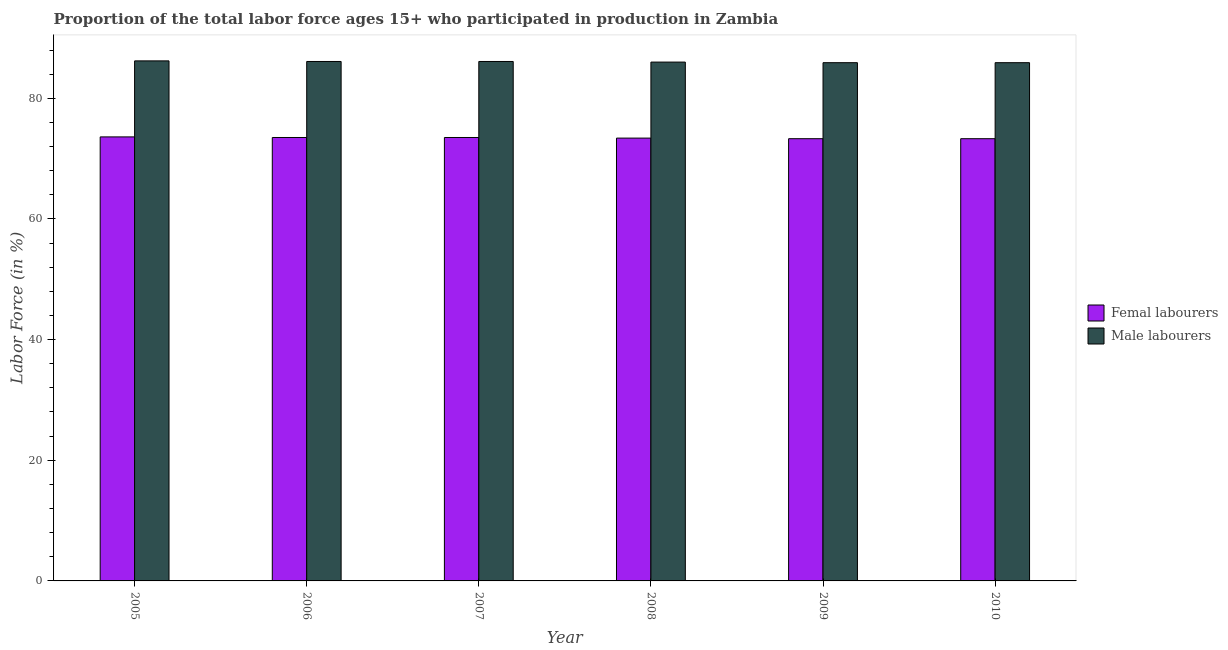How many different coloured bars are there?
Ensure brevity in your answer.  2. How many groups of bars are there?
Your answer should be very brief. 6. Are the number of bars on each tick of the X-axis equal?
Your response must be concise. Yes. How many bars are there on the 3rd tick from the right?
Keep it short and to the point. 2. What is the label of the 1st group of bars from the left?
Keep it short and to the point. 2005. What is the percentage of male labour force in 2006?
Provide a short and direct response. 86.1. Across all years, what is the maximum percentage of male labour force?
Offer a very short reply. 86.2. Across all years, what is the minimum percentage of female labor force?
Provide a short and direct response. 73.3. In which year was the percentage of female labor force minimum?
Ensure brevity in your answer.  2009. What is the total percentage of male labour force in the graph?
Make the answer very short. 516.2. What is the difference between the percentage of female labor force in 2009 and that in 2010?
Offer a terse response. 0. What is the difference between the percentage of female labor force in 2006 and the percentage of male labour force in 2010?
Your answer should be very brief. 0.2. What is the average percentage of female labor force per year?
Your response must be concise. 73.43. What is the ratio of the percentage of male labour force in 2005 to that in 2007?
Your response must be concise. 1. What is the difference between the highest and the second highest percentage of male labour force?
Keep it short and to the point. 0.1. What is the difference between the highest and the lowest percentage of female labor force?
Make the answer very short. 0.3. Is the sum of the percentage of female labor force in 2007 and 2008 greater than the maximum percentage of male labour force across all years?
Give a very brief answer. Yes. What does the 2nd bar from the left in 2006 represents?
Provide a short and direct response. Male labourers. What does the 2nd bar from the right in 2009 represents?
Your response must be concise. Femal labourers. How many bars are there?
Give a very brief answer. 12. How many years are there in the graph?
Your answer should be very brief. 6. Are the values on the major ticks of Y-axis written in scientific E-notation?
Your answer should be very brief. No. Does the graph contain any zero values?
Offer a very short reply. No. Does the graph contain grids?
Ensure brevity in your answer.  No. How many legend labels are there?
Provide a short and direct response. 2. What is the title of the graph?
Provide a succinct answer. Proportion of the total labor force ages 15+ who participated in production in Zambia. Does "Personal remittances" appear as one of the legend labels in the graph?
Keep it short and to the point. No. What is the label or title of the X-axis?
Your answer should be very brief. Year. What is the label or title of the Y-axis?
Offer a very short reply. Labor Force (in %). What is the Labor Force (in %) in Femal labourers in 2005?
Your answer should be very brief. 73.6. What is the Labor Force (in %) of Male labourers in 2005?
Make the answer very short. 86.2. What is the Labor Force (in %) in Femal labourers in 2006?
Your response must be concise. 73.5. What is the Labor Force (in %) of Male labourers in 2006?
Make the answer very short. 86.1. What is the Labor Force (in %) in Femal labourers in 2007?
Offer a very short reply. 73.5. What is the Labor Force (in %) of Male labourers in 2007?
Your answer should be very brief. 86.1. What is the Labor Force (in %) in Femal labourers in 2008?
Offer a very short reply. 73.4. What is the Labor Force (in %) in Femal labourers in 2009?
Provide a short and direct response. 73.3. What is the Labor Force (in %) in Male labourers in 2009?
Give a very brief answer. 85.9. What is the Labor Force (in %) of Femal labourers in 2010?
Offer a terse response. 73.3. What is the Labor Force (in %) in Male labourers in 2010?
Offer a very short reply. 85.9. Across all years, what is the maximum Labor Force (in %) of Femal labourers?
Ensure brevity in your answer.  73.6. Across all years, what is the maximum Labor Force (in %) in Male labourers?
Give a very brief answer. 86.2. Across all years, what is the minimum Labor Force (in %) in Femal labourers?
Your answer should be very brief. 73.3. Across all years, what is the minimum Labor Force (in %) of Male labourers?
Provide a succinct answer. 85.9. What is the total Labor Force (in %) of Femal labourers in the graph?
Your response must be concise. 440.6. What is the total Labor Force (in %) in Male labourers in the graph?
Provide a succinct answer. 516.2. What is the difference between the Labor Force (in %) in Male labourers in 2005 and that in 2006?
Make the answer very short. 0.1. What is the difference between the Labor Force (in %) of Male labourers in 2005 and that in 2007?
Your answer should be very brief. 0.1. What is the difference between the Labor Force (in %) of Femal labourers in 2005 and that in 2008?
Offer a terse response. 0.2. What is the difference between the Labor Force (in %) in Femal labourers in 2005 and that in 2009?
Give a very brief answer. 0.3. What is the difference between the Labor Force (in %) of Male labourers in 2005 and that in 2009?
Keep it short and to the point. 0.3. What is the difference between the Labor Force (in %) of Femal labourers in 2005 and that in 2010?
Your answer should be compact. 0.3. What is the difference between the Labor Force (in %) in Male labourers in 2005 and that in 2010?
Offer a terse response. 0.3. What is the difference between the Labor Force (in %) of Femal labourers in 2006 and that in 2008?
Provide a short and direct response. 0.1. What is the difference between the Labor Force (in %) in Male labourers in 2006 and that in 2008?
Keep it short and to the point. 0.1. What is the difference between the Labor Force (in %) of Femal labourers in 2006 and that in 2009?
Offer a very short reply. 0.2. What is the difference between the Labor Force (in %) in Male labourers in 2006 and that in 2009?
Ensure brevity in your answer.  0.2. What is the difference between the Labor Force (in %) in Male labourers in 2006 and that in 2010?
Provide a short and direct response. 0.2. What is the difference between the Labor Force (in %) of Male labourers in 2007 and that in 2008?
Provide a short and direct response. 0.1. What is the difference between the Labor Force (in %) in Male labourers in 2008 and that in 2009?
Give a very brief answer. 0.1. What is the difference between the Labor Force (in %) of Male labourers in 2008 and that in 2010?
Your answer should be compact. 0.1. What is the difference between the Labor Force (in %) in Femal labourers in 2009 and that in 2010?
Give a very brief answer. 0. What is the difference between the Labor Force (in %) of Femal labourers in 2005 and the Labor Force (in %) of Male labourers in 2006?
Offer a terse response. -12.5. What is the difference between the Labor Force (in %) of Femal labourers in 2005 and the Labor Force (in %) of Male labourers in 2007?
Keep it short and to the point. -12.5. What is the difference between the Labor Force (in %) in Femal labourers in 2005 and the Labor Force (in %) in Male labourers in 2010?
Keep it short and to the point. -12.3. What is the difference between the Labor Force (in %) in Femal labourers in 2006 and the Labor Force (in %) in Male labourers in 2007?
Your response must be concise. -12.6. What is the difference between the Labor Force (in %) of Femal labourers in 2006 and the Labor Force (in %) of Male labourers in 2008?
Provide a succinct answer. -12.5. What is the difference between the Labor Force (in %) in Femal labourers in 2006 and the Labor Force (in %) in Male labourers in 2010?
Your answer should be compact. -12.4. What is the difference between the Labor Force (in %) in Femal labourers in 2007 and the Labor Force (in %) in Male labourers in 2010?
Offer a very short reply. -12.4. What is the difference between the Labor Force (in %) in Femal labourers in 2008 and the Labor Force (in %) in Male labourers in 2010?
Your answer should be compact. -12.5. What is the difference between the Labor Force (in %) of Femal labourers in 2009 and the Labor Force (in %) of Male labourers in 2010?
Keep it short and to the point. -12.6. What is the average Labor Force (in %) of Femal labourers per year?
Your response must be concise. 73.43. What is the average Labor Force (in %) in Male labourers per year?
Your response must be concise. 86.03. In the year 2005, what is the difference between the Labor Force (in %) of Femal labourers and Labor Force (in %) of Male labourers?
Your answer should be very brief. -12.6. In the year 2006, what is the difference between the Labor Force (in %) in Femal labourers and Labor Force (in %) in Male labourers?
Offer a very short reply. -12.6. In the year 2007, what is the difference between the Labor Force (in %) of Femal labourers and Labor Force (in %) of Male labourers?
Your response must be concise. -12.6. In the year 2010, what is the difference between the Labor Force (in %) in Femal labourers and Labor Force (in %) in Male labourers?
Your answer should be compact. -12.6. What is the ratio of the Labor Force (in %) in Femal labourers in 2005 to that in 2007?
Your answer should be very brief. 1. What is the ratio of the Labor Force (in %) of Femal labourers in 2005 to that in 2008?
Your answer should be very brief. 1. What is the ratio of the Labor Force (in %) in Male labourers in 2005 to that in 2008?
Your answer should be compact. 1. What is the ratio of the Labor Force (in %) in Femal labourers in 2005 to that in 2009?
Your answer should be very brief. 1. What is the ratio of the Labor Force (in %) in Femal labourers in 2006 to that in 2007?
Provide a succinct answer. 1. What is the ratio of the Labor Force (in %) of Male labourers in 2006 to that in 2008?
Offer a very short reply. 1. What is the ratio of the Labor Force (in %) of Femal labourers in 2006 to that in 2009?
Provide a succinct answer. 1. What is the ratio of the Labor Force (in %) in Femal labourers in 2006 to that in 2010?
Offer a terse response. 1. What is the ratio of the Labor Force (in %) of Male labourers in 2006 to that in 2010?
Provide a short and direct response. 1. What is the ratio of the Labor Force (in %) in Male labourers in 2007 to that in 2008?
Make the answer very short. 1. What is the ratio of the Labor Force (in %) in Male labourers in 2007 to that in 2009?
Your answer should be compact. 1. What is the ratio of the Labor Force (in %) in Femal labourers in 2007 to that in 2010?
Make the answer very short. 1. What is the ratio of the Labor Force (in %) of Male labourers in 2007 to that in 2010?
Your answer should be very brief. 1. What is the ratio of the Labor Force (in %) of Male labourers in 2008 to that in 2009?
Provide a short and direct response. 1. What is the ratio of the Labor Force (in %) in Femal labourers in 2009 to that in 2010?
Your response must be concise. 1. What is the difference between the highest and the second highest Labor Force (in %) in Femal labourers?
Provide a short and direct response. 0.1. What is the difference between the highest and the second highest Labor Force (in %) in Male labourers?
Offer a terse response. 0.1. What is the difference between the highest and the lowest Labor Force (in %) of Femal labourers?
Offer a terse response. 0.3. What is the difference between the highest and the lowest Labor Force (in %) in Male labourers?
Provide a short and direct response. 0.3. 